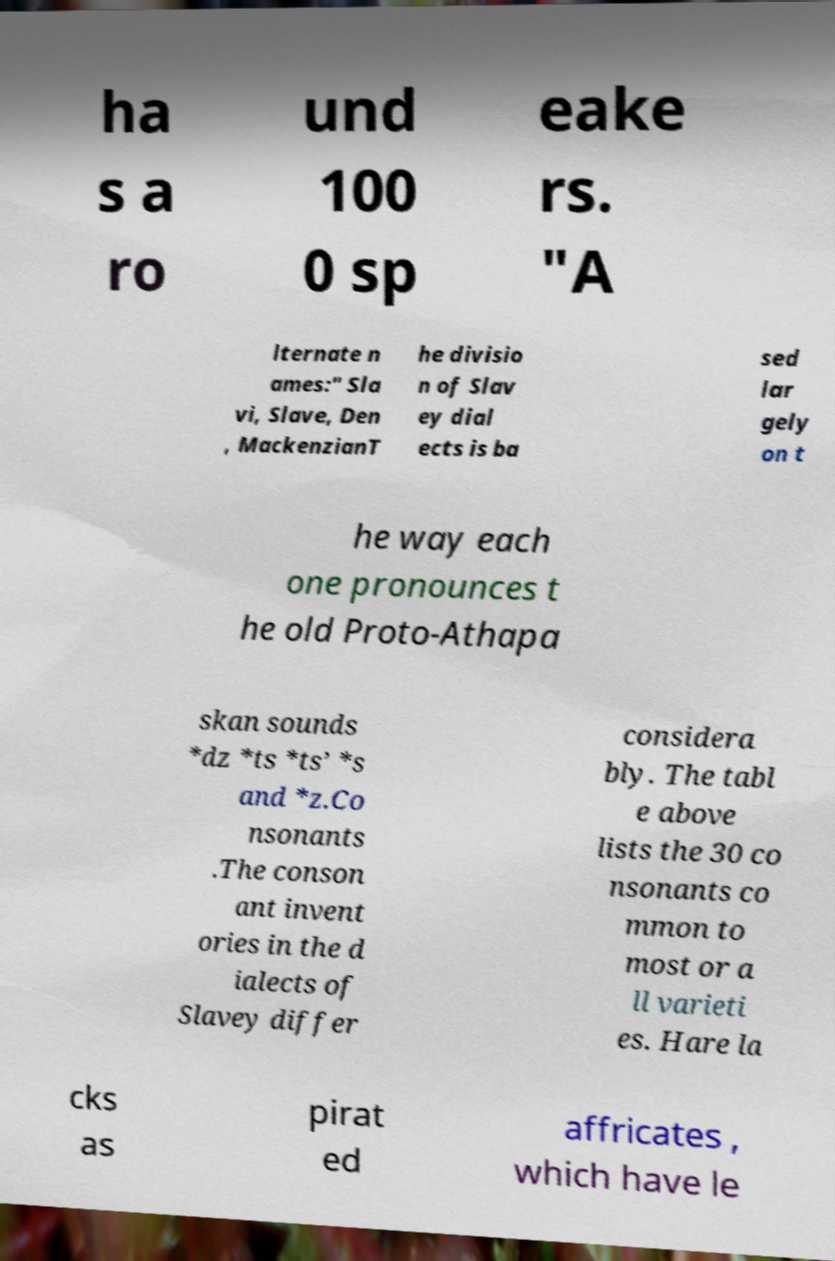What messages or text are displayed in this image? I need them in a readable, typed format. ha s a ro und 100 0 sp eake rs. "A lternate n ames:" Sla vi, Slave, Den , MackenzianT he divisio n of Slav ey dial ects is ba sed lar gely on t he way each one pronounces t he old Proto-Athapa skan sounds *dz *ts *ts’ *s and *z.Co nsonants .The conson ant invent ories in the d ialects of Slavey differ considera bly. The tabl e above lists the 30 co nsonants co mmon to most or a ll varieti es. Hare la cks as pirat ed affricates , which have le 